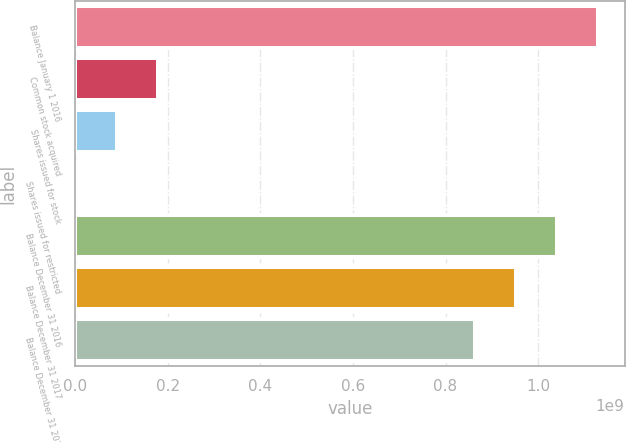Convert chart. <chart><loc_0><loc_0><loc_500><loc_500><bar_chart><fcel>Balance January 1 2016<fcel>Common stock acquired<fcel>Shares issued for stock<fcel>Shares issued for restricted<fcel>Balance December 31 2016<fcel>Balance December 31 2017<fcel>Balance December 31 2018<nl><fcel>1.1304e+09<fcel>1.79432e+08<fcel>9.02685e+07<fcel>1.10511e+06<fcel>1.04124e+09<fcel>9.52076e+08<fcel>8.62913e+08<nl></chart> 